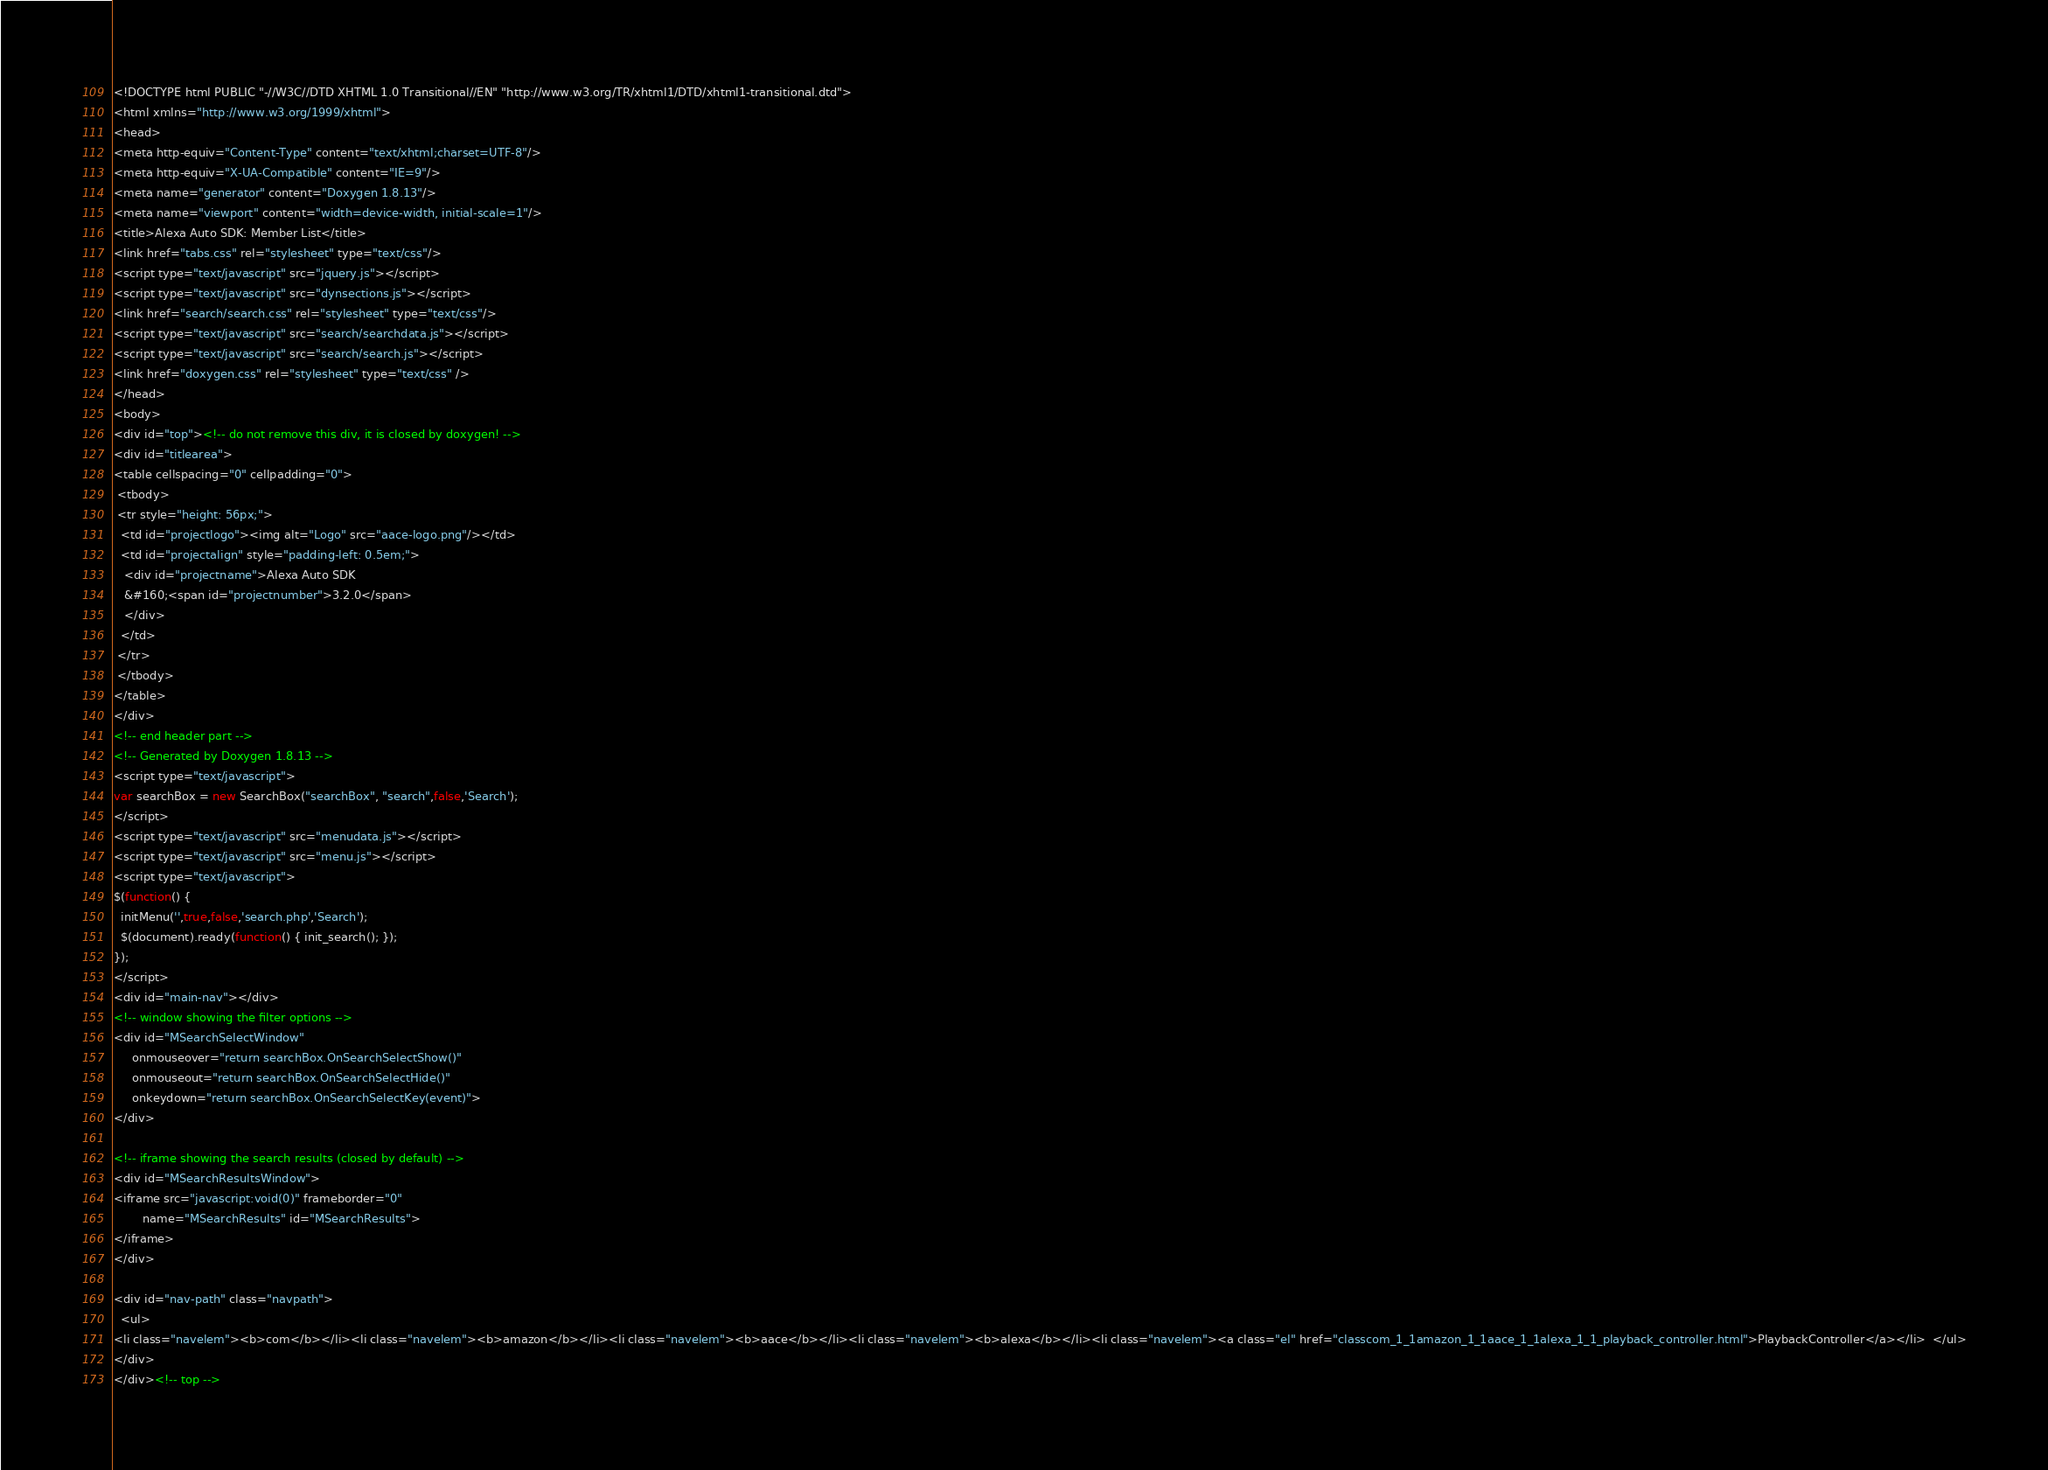Convert code to text. <code><loc_0><loc_0><loc_500><loc_500><_HTML_><!DOCTYPE html PUBLIC "-//W3C//DTD XHTML 1.0 Transitional//EN" "http://www.w3.org/TR/xhtml1/DTD/xhtml1-transitional.dtd">
<html xmlns="http://www.w3.org/1999/xhtml">
<head>
<meta http-equiv="Content-Type" content="text/xhtml;charset=UTF-8"/>
<meta http-equiv="X-UA-Compatible" content="IE=9"/>
<meta name="generator" content="Doxygen 1.8.13"/>
<meta name="viewport" content="width=device-width, initial-scale=1"/>
<title>Alexa Auto SDK: Member List</title>
<link href="tabs.css" rel="stylesheet" type="text/css"/>
<script type="text/javascript" src="jquery.js"></script>
<script type="text/javascript" src="dynsections.js"></script>
<link href="search/search.css" rel="stylesheet" type="text/css"/>
<script type="text/javascript" src="search/searchdata.js"></script>
<script type="text/javascript" src="search/search.js"></script>
<link href="doxygen.css" rel="stylesheet" type="text/css" />
</head>
<body>
<div id="top"><!-- do not remove this div, it is closed by doxygen! -->
<div id="titlearea">
<table cellspacing="0" cellpadding="0">
 <tbody>
 <tr style="height: 56px;">
  <td id="projectlogo"><img alt="Logo" src="aace-logo.png"/></td>
  <td id="projectalign" style="padding-left: 0.5em;">
   <div id="projectname">Alexa Auto SDK
   &#160;<span id="projectnumber">3.2.0</span>
   </div>
  </td>
 </tr>
 </tbody>
</table>
</div>
<!-- end header part -->
<!-- Generated by Doxygen 1.8.13 -->
<script type="text/javascript">
var searchBox = new SearchBox("searchBox", "search",false,'Search');
</script>
<script type="text/javascript" src="menudata.js"></script>
<script type="text/javascript" src="menu.js"></script>
<script type="text/javascript">
$(function() {
  initMenu('',true,false,'search.php','Search');
  $(document).ready(function() { init_search(); });
});
</script>
<div id="main-nav"></div>
<!-- window showing the filter options -->
<div id="MSearchSelectWindow"
     onmouseover="return searchBox.OnSearchSelectShow()"
     onmouseout="return searchBox.OnSearchSelectHide()"
     onkeydown="return searchBox.OnSearchSelectKey(event)">
</div>

<!-- iframe showing the search results (closed by default) -->
<div id="MSearchResultsWindow">
<iframe src="javascript:void(0)" frameborder="0" 
        name="MSearchResults" id="MSearchResults">
</iframe>
</div>

<div id="nav-path" class="navpath">
  <ul>
<li class="navelem"><b>com</b></li><li class="navelem"><b>amazon</b></li><li class="navelem"><b>aace</b></li><li class="navelem"><b>alexa</b></li><li class="navelem"><a class="el" href="classcom_1_1amazon_1_1aace_1_1alexa_1_1_playback_controller.html">PlaybackController</a></li>  </ul>
</div>
</div><!-- top --></code> 